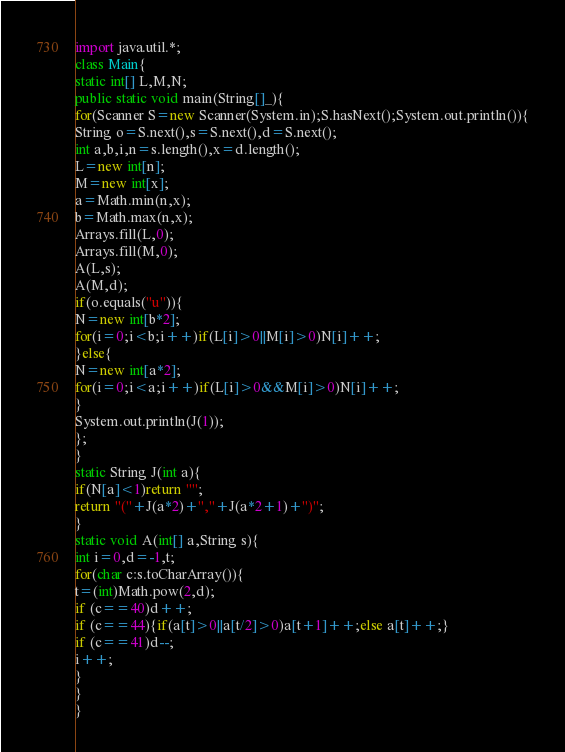Convert code to text. <code><loc_0><loc_0><loc_500><loc_500><_Java_>import java.util.*;
class Main{
static int[] L,M,N;
public static void main(String[]_){
for(Scanner S=new Scanner(System.in);S.hasNext();System.out.println()){
String o=S.next(),s=S.next(),d=S.next();
int a,b,i,n=s.length(),x=d.length();
L=new int[n];
M=new int[x];
a=Math.min(n,x);
b=Math.max(n,x);
Arrays.fill(L,0);
Arrays.fill(M,0);
A(L,s);
A(M,d);
if(o.equals("u")){
N=new int[b*2];
for(i=0;i<b;i++)if(L[i]>0||M[i]>0)N[i]++;
}else{
N=new int[a*2];
for(i=0;i<a;i++)if(L[i]>0&&M[i]>0)N[i]++;
}
System.out.println(J(1));
};
}
static String J(int a){
if(N[a]<1)return "";
return "("+J(a*2)+","+J(a*2+1)+")";
}
static void A(int[] a,String s){
int i=0,d=-1,t;
for(char c:s.toCharArray()){
t=(int)Math.pow(2,d);
if (c==40)d++;
if (c==44){if(a[t]>0||a[t/2]>0)a[t+1]++;else a[t]++;}
if (c==41)d--;
i++;
}
}
}</code> 